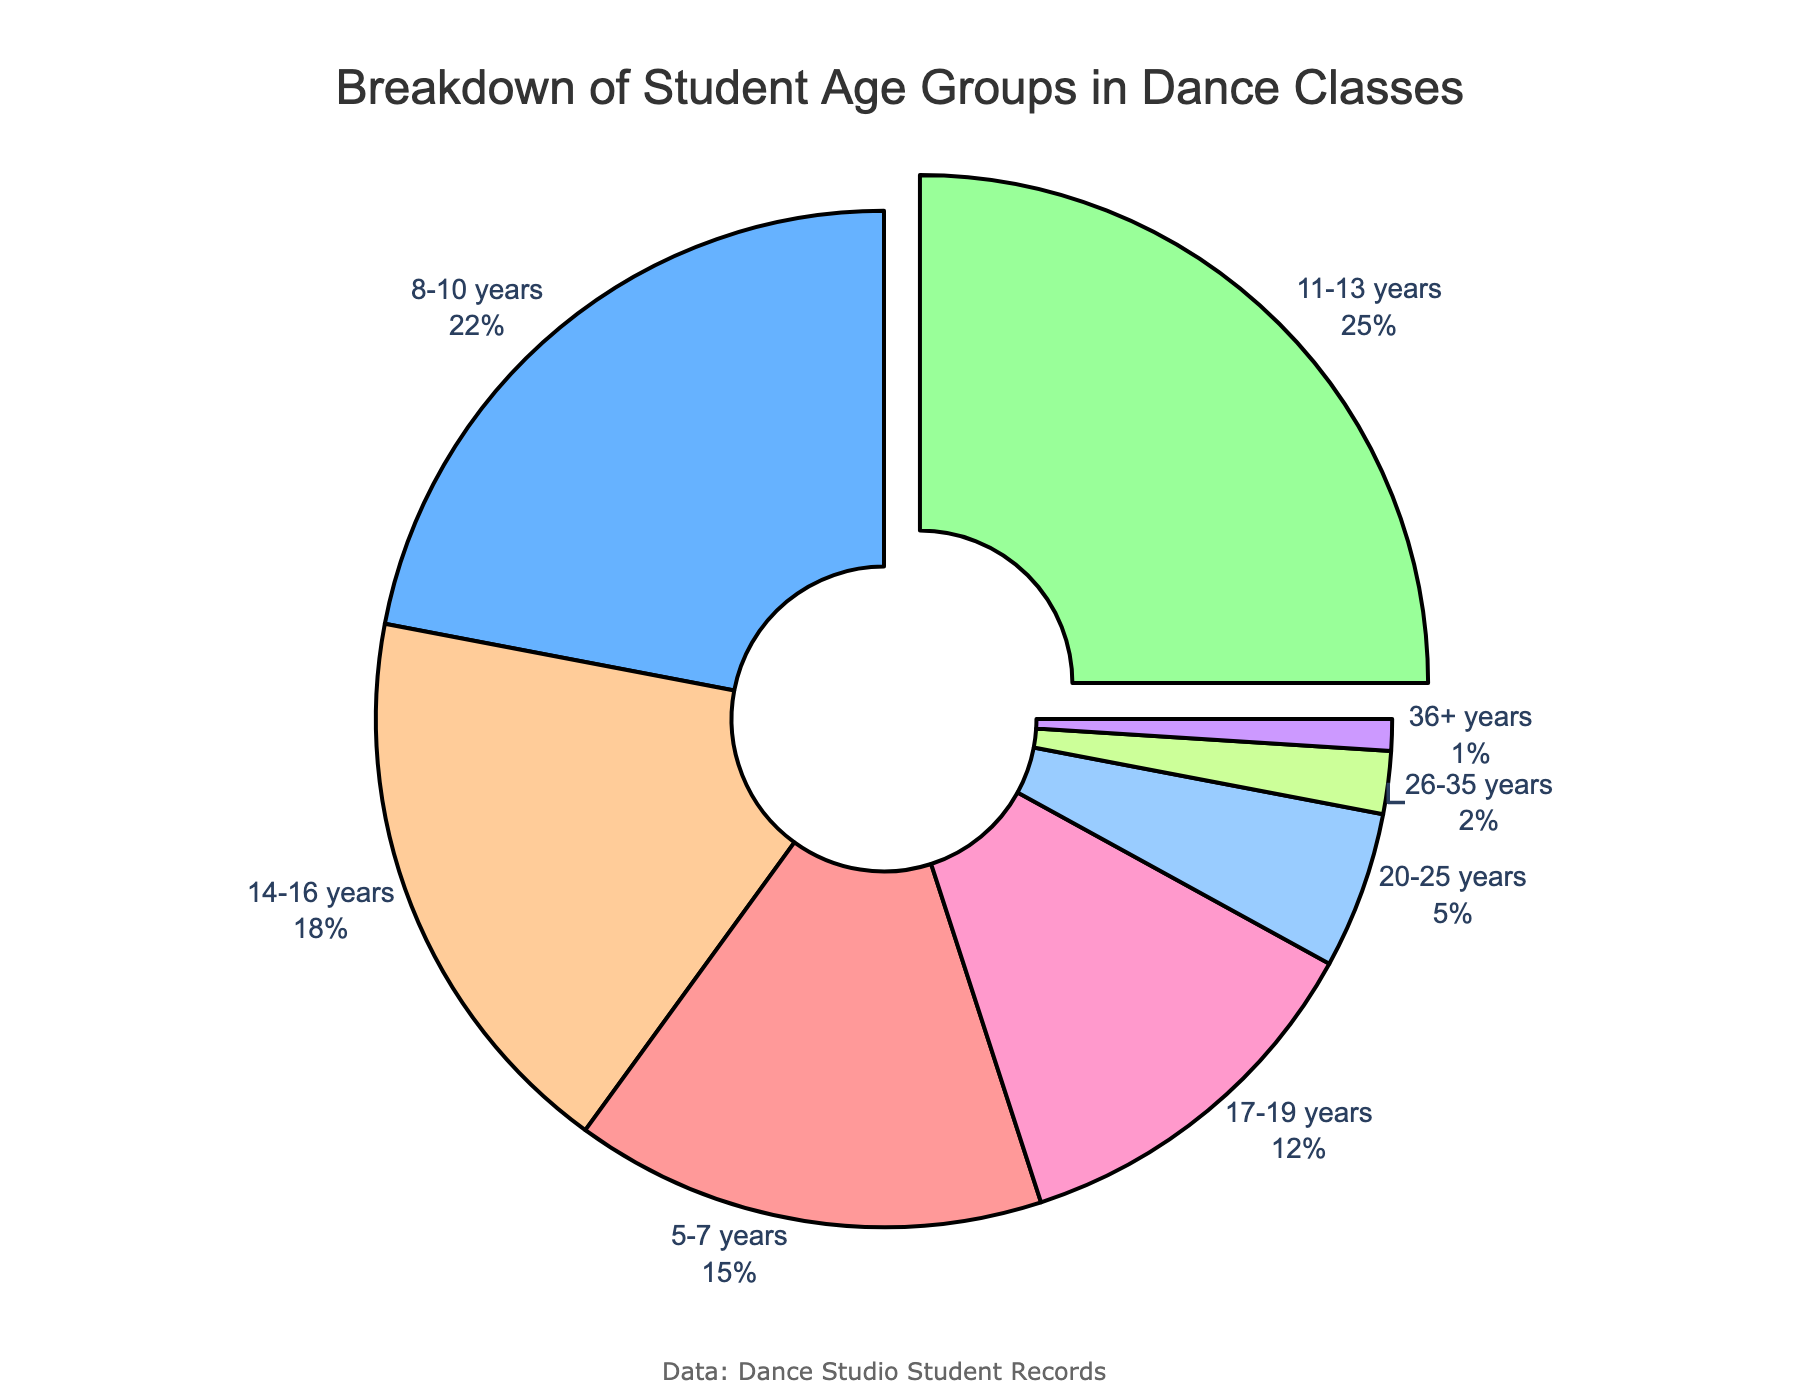What's the age group with the highest percentage of students? Identify the largest pie slice, which is the age group 11-13 years with 25%.
Answer: 11-13 years What is the total percentage represented by students aged 10 years or younger? Add the percentages of the groups 5-7 years (15%) and 8-10 years (22%): 15% + 22% = 37%.
Answer: 37% Which age group has the smallest representation in the dance classes? Identify the smallest pie slice, which is the age group 36+ years with 1%.
Answer: 36+ years How much larger is the percentage of students aged 14-16 years compared to students aged 20-25 years? Subtract the percentage of 20-25 years (5%) from the percentage of 14-16 years (18%): 18% - 5% = 13%.
Answer: 13% How does the percentage of students aged 17-19 years compare to those aged 8-10 years? Compare the percentages, 17-19 years has 12% and 8-10 years has 22%. 8-10 years has a higher percentage.
Answer: 8-10 years What is the combined percentage of students aged 20 years and older? Add the percentages of the groups 20-25 years (5%), 26-35 years (2%), and 36+ years (1%): 5% + 2% + 1% = 8%.
Answer: 8% Which age group is represented with the light blue color? Identify the color coding for the age group with the light blue pie slice, which is the 8-10 years with 22%.
Answer: 8-10 years What is the difference in percentages between the 5-7 years and 26-35 years age groups? Subtract the percentage of 26-35 years (2%) from the percentage of 5-7 years (15%): 15% - 2% = 13%.
Answer: 13% Which two age groups have a combined percentage of over 40%? Identify the age groups and their percentages, 8-10 years (22%) and 11-13 years (25%) together have 22% + 25% = 47%.
Answer: 8-10 years and 11-13 years 